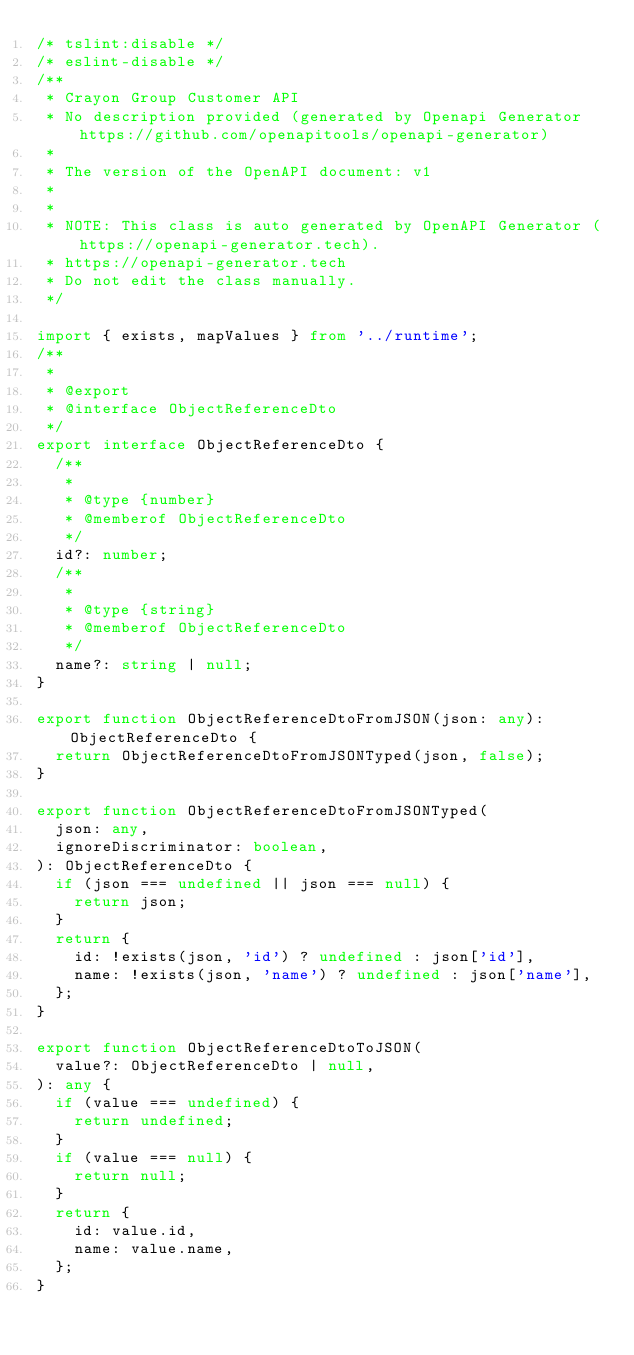<code> <loc_0><loc_0><loc_500><loc_500><_TypeScript_>/* tslint:disable */
/* eslint-disable */
/**
 * Crayon Group Customer API
 * No description provided (generated by Openapi Generator https://github.com/openapitools/openapi-generator)
 *
 * The version of the OpenAPI document: v1
 *
 *
 * NOTE: This class is auto generated by OpenAPI Generator (https://openapi-generator.tech).
 * https://openapi-generator.tech
 * Do not edit the class manually.
 */

import { exists, mapValues } from '../runtime';
/**
 *
 * @export
 * @interface ObjectReferenceDto
 */
export interface ObjectReferenceDto {
  /**
   *
   * @type {number}
   * @memberof ObjectReferenceDto
   */
  id?: number;
  /**
   *
   * @type {string}
   * @memberof ObjectReferenceDto
   */
  name?: string | null;
}

export function ObjectReferenceDtoFromJSON(json: any): ObjectReferenceDto {
  return ObjectReferenceDtoFromJSONTyped(json, false);
}

export function ObjectReferenceDtoFromJSONTyped(
  json: any,
  ignoreDiscriminator: boolean,
): ObjectReferenceDto {
  if (json === undefined || json === null) {
    return json;
  }
  return {
    id: !exists(json, 'id') ? undefined : json['id'],
    name: !exists(json, 'name') ? undefined : json['name'],
  };
}

export function ObjectReferenceDtoToJSON(
  value?: ObjectReferenceDto | null,
): any {
  if (value === undefined) {
    return undefined;
  }
  if (value === null) {
    return null;
  }
  return {
    id: value.id,
    name: value.name,
  };
}
</code> 